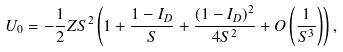Convert formula to latex. <formula><loc_0><loc_0><loc_500><loc_500>U _ { 0 } = - \frac { 1 } { 2 } Z S ^ { 2 } \left ( 1 + \frac { 1 - I _ { D } } { S } + \frac { ( 1 - I _ { D } ) ^ { 2 } } { 4 S ^ { 2 } } + O \left ( \frac { 1 } { S ^ { 3 } } \right ) \right ) ,</formula> 